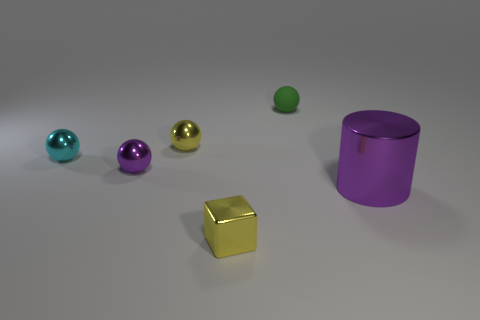How large would you estimate the gold cube to be compared to the other objects? Based on its appearance in the image, the gold cube seems to be modestly sized, smaller than the large purple cylinder and slightly larger than the small green sphere. Such comparisons can only roughly estimate size without exact measurements. 